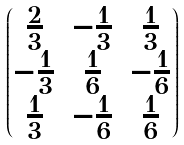Convert formula to latex. <formula><loc_0><loc_0><loc_500><loc_500>\begin{pmatrix} \frac { 2 } { 3 } & - \frac { 1 } { 3 } & \frac { 1 } { 3 } \\ - \frac { 1 } { 3 } & \frac { 1 } { 6 } & - \frac { 1 } { 6 } \\ \frac { 1 } { 3 } & - \frac { 1 } { 6 } & \frac { 1 } { 6 } \end{pmatrix}</formula> 